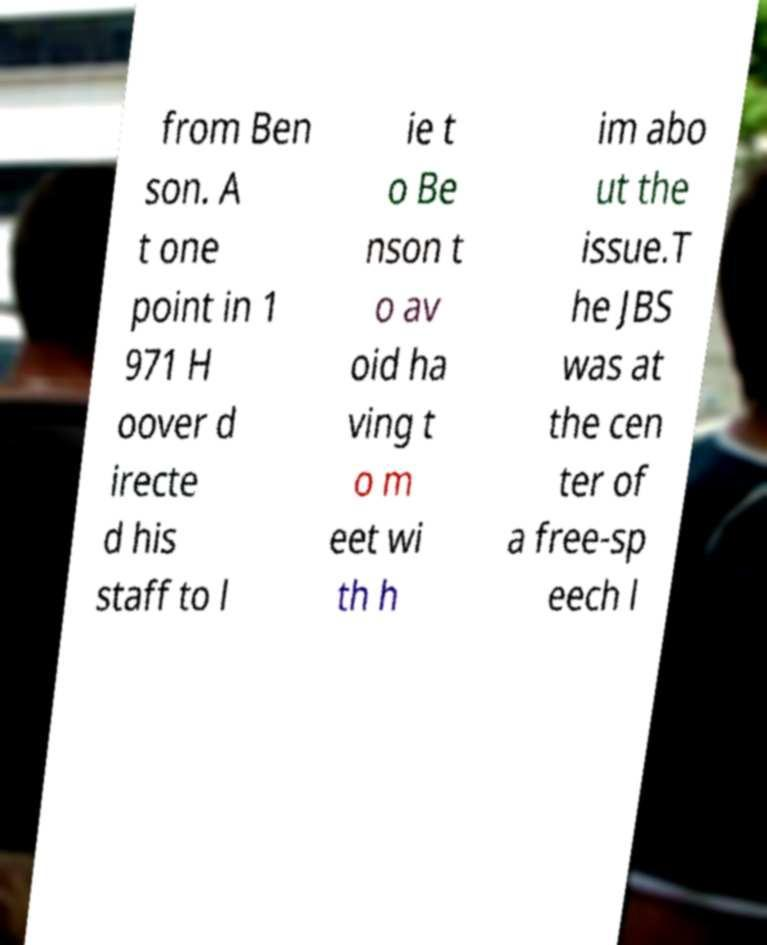Could you extract and type out the text from this image? from Ben son. A t one point in 1 971 H oover d irecte d his staff to l ie t o Be nson t o av oid ha ving t o m eet wi th h im abo ut the issue.T he JBS was at the cen ter of a free-sp eech l 